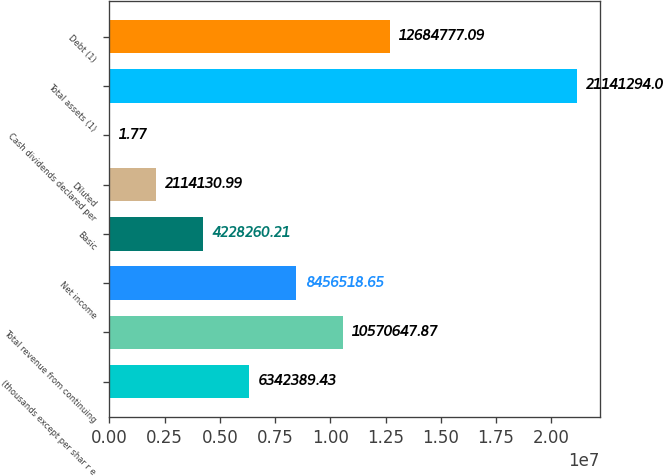Convert chart to OTSL. <chart><loc_0><loc_0><loc_500><loc_500><bar_chart><fcel>(thousands except per shar r e<fcel>Total revenue from continuing<fcel>Net income<fcel>Basic<fcel>Diluted<fcel>Cash dividends declared per<fcel>Total assets (1)<fcel>Debt (1)<nl><fcel>6.34239e+06<fcel>1.05706e+07<fcel>8.45652e+06<fcel>4.22826e+06<fcel>2.11413e+06<fcel>1.77<fcel>2.11413e+07<fcel>1.26848e+07<nl></chart> 